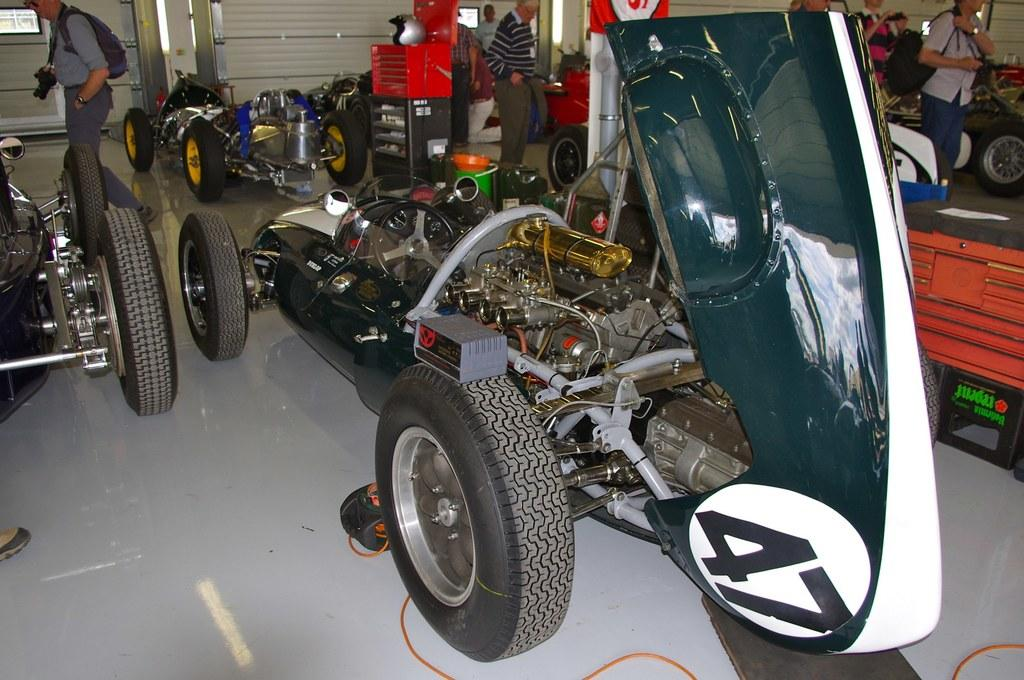What can be seen in the image? There are vehicles and people in the image. Can you describe the person in front? The person in front is wearing a gray shirt and holding a camera. What are the people in the image doing? It is not clear what the people are doing, but they are standing in the image. What can be seen in the background of the image? There are objects visible in the background of the image. What type of meal is being prepared by the horses in the image? There are no horses present in the image, so it is not possible to answer that question. 